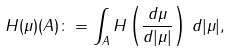Convert formula to latex. <formula><loc_0><loc_0><loc_500><loc_500>H ( \mu ) ( A ) \colon = \int _ { A } H \left ( \frac { d \mu } { d | \mu | } \right ) \, d | \mu | ,</formula> 